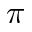<formula> <loc_0><loc_0><loc_500><loc_500>\pi</formula> 